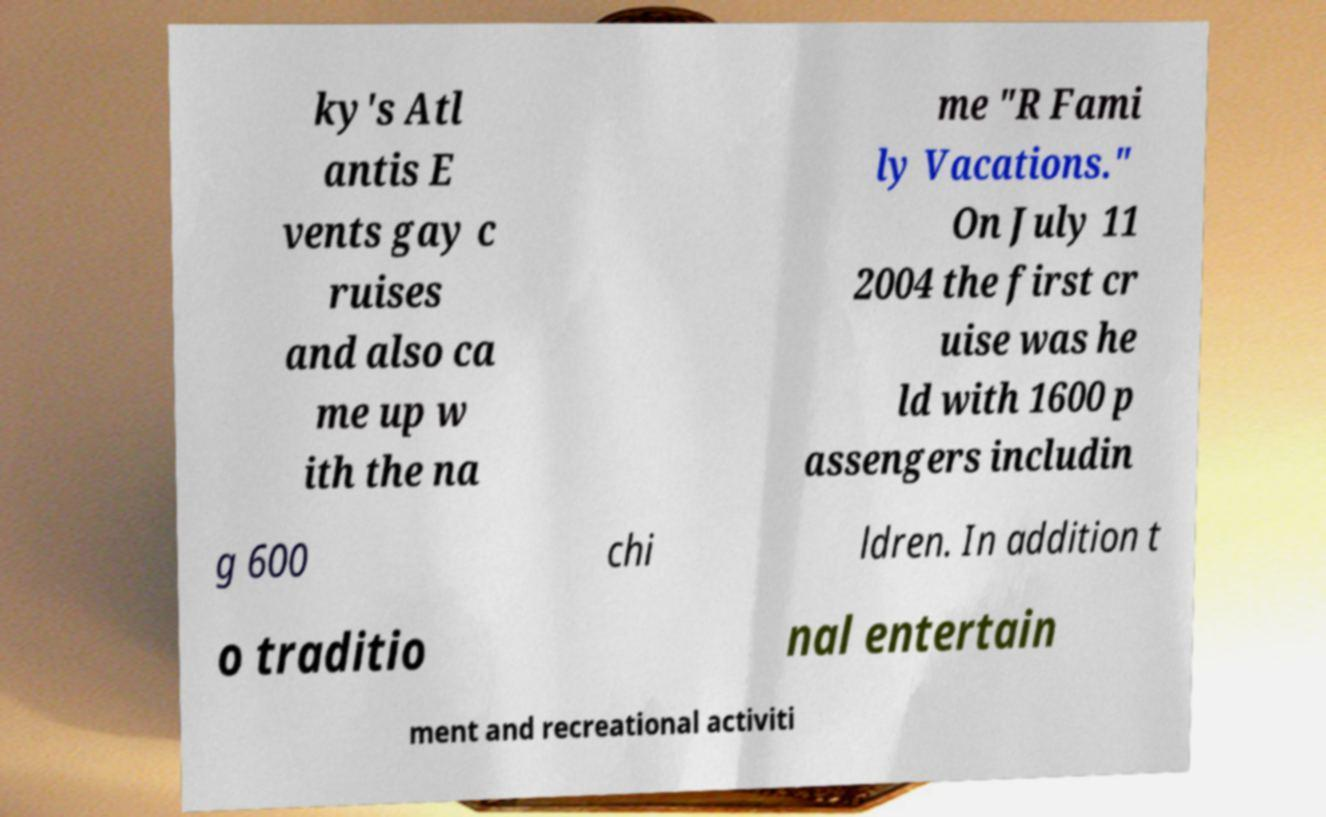For documentation purposes, I need the text within this image transcribed. Could you provide that? ky's Atl antis E vents gay c ruises and also ca me up w ith the na me "R Fami ly Vacations." On July 11 2004 the first cr uise was he ld with 1600 p assengers includin g 600 chi ldren. In addition t o traditio nal entertain ment and recreational activiti 